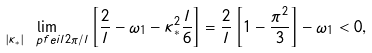<formula> <loc_0><loc_0><loc_500><loc_500>\lim _ { | \kappa _ { * } | \ p f e i l 2 \pi / l } \left [ \frac { 2 } { l } - \omega _ { 1 } - \kappa _ { * } ^ { 2 } \frac { l } { 6 } \right ] = \frac { 2 } { l } \left [ 1 - \frac { \pi ^ { 2 } } { 3 } \right ] - \omega _ { 1 } < 0 ,</formula> 